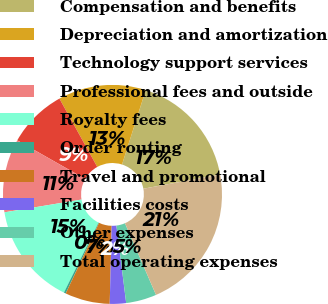Convert chart. <chart><loc_0><loc_0><loc_500><loc_500><pie_chart><fcel>Compensation and benefits<fcel>Depreciation and amortization<fcel>Technology support services<fcel>Professional fees and outside<fcel>Royalty fees<fcel>Order routing<fcel>Travel and promotional<fcel>Facilities costs<fcel>Other expenses<fcel>Total operating expenses<nl><fcel>17.18%<fcel>12.96%<fcel>8.73%<fcel>10.84%<fcel>15.07%<fcel>0.29%<fcel>6.62%<fcel>2.4%<fcel>4.51%<fcel>21.4%<nl></chart> 